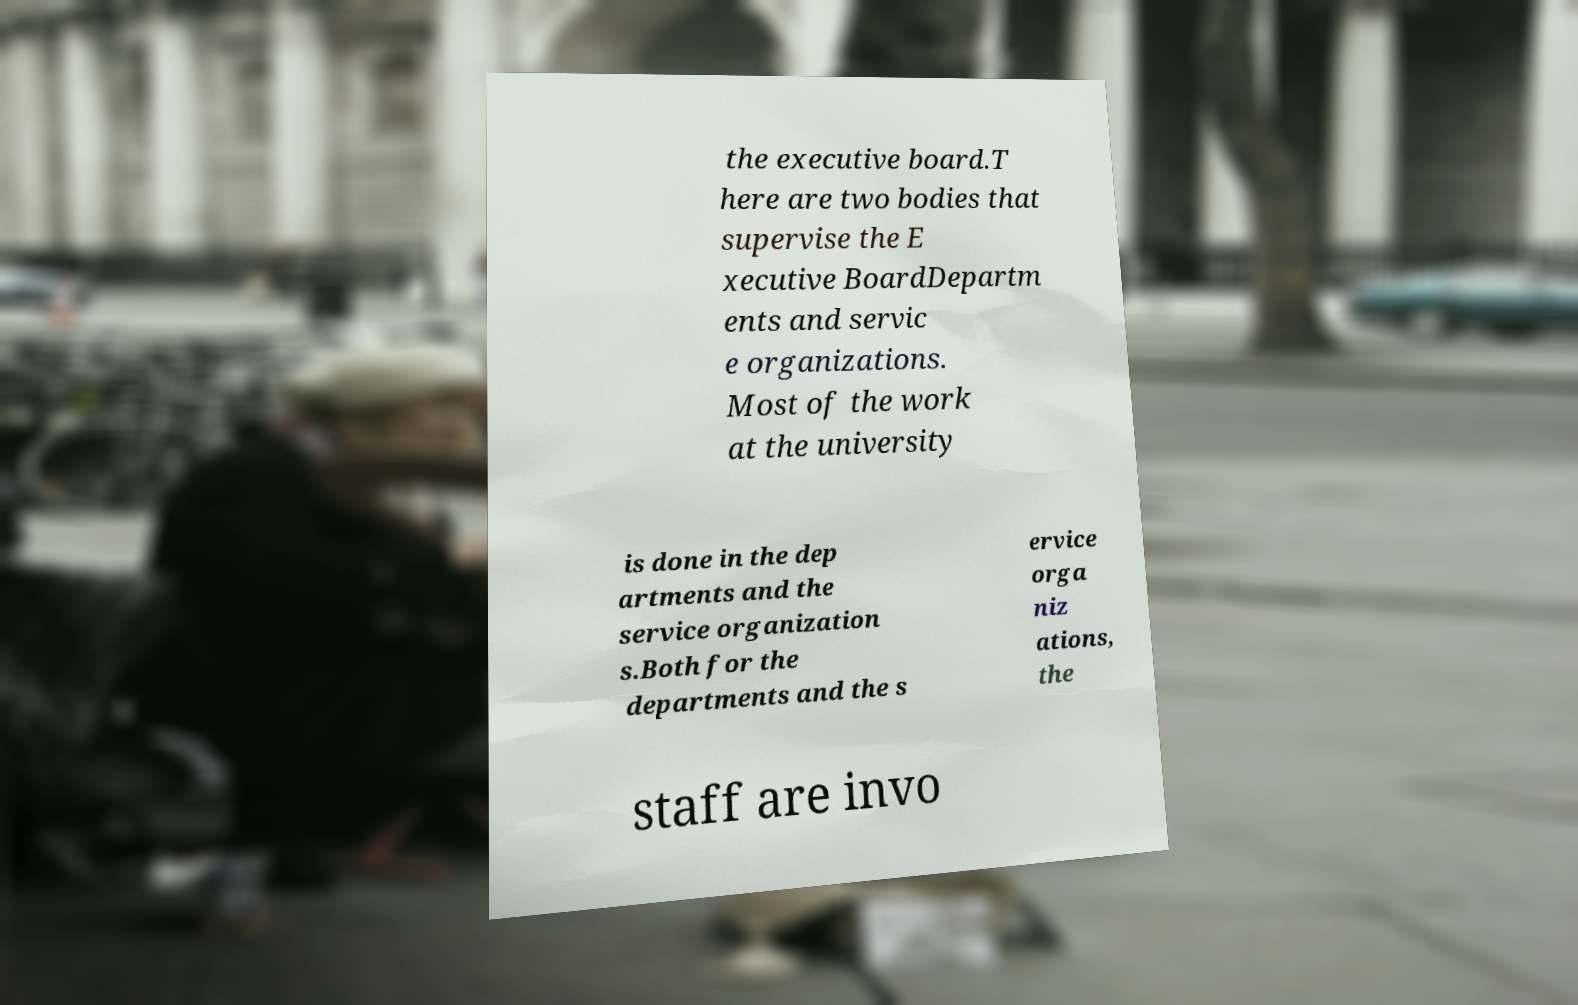Can you accurately transcribe the text from the provided image for me? the executive board.T here are two bodies that supervise the E xecutive BoardDepartm ents and servic e organizations. Most of the work at the university is done in the dep artments and the service organization s.Both for the departments and the s ervice orga niz ations, the staff are invo 